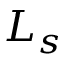Convert formula to latex. <formula><loc_0><loc_0><loc_500><loc_500>L _ { s }</formula> 